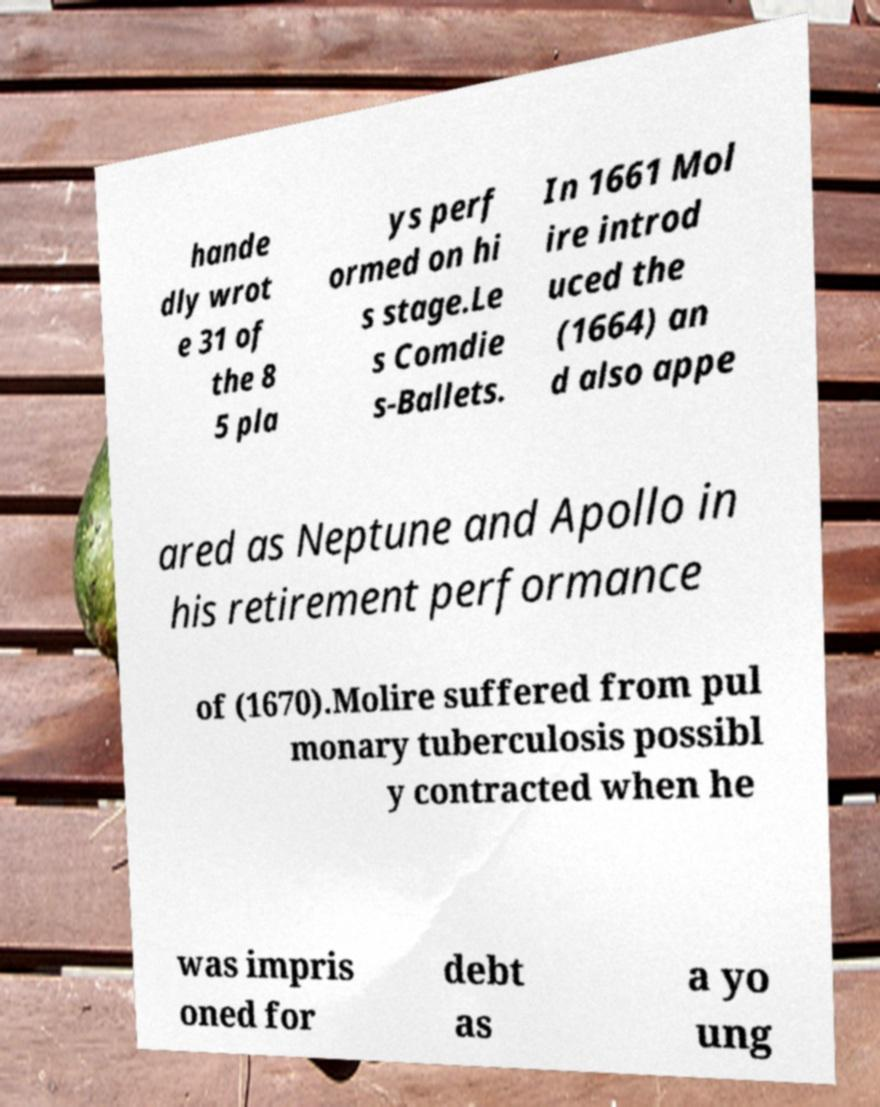What messages or text are displayed in this image? I need them in a readable, typed format. hande dly wrot e 31 of the 8 5 pla ys perf ormed on hi s stage.Le s Comdie s-Ballets. In 1661 Mol ire introd uced the (1664) an d also appe ared as Neptune and Apollo in his retirement performance of (1670).Molire suffered from pul monary tuberculosis possibl y contracted when he was impris oned for debt as a yo ung 